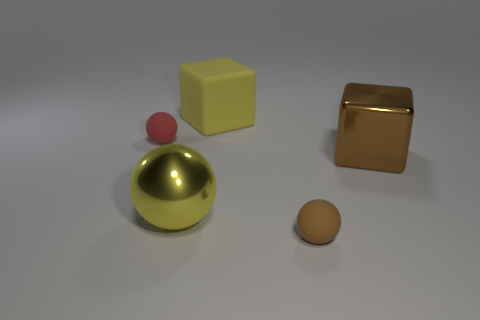There is a metallic thing that is the same shape as the yellow rubber object; what is its size?
Keep it short and to the point. Large. What number of other balls are made of the same material as the yellow ball?
Make the answer very short. 0. What material is the yellow sphere?
Keep it short and to the point. Metal. What is the shape of the small thing behind the metal cube that is in front of the red ball?
Offer a very short reply. Sphere. What is the shape of the yellow object that is to the left of the big matte thing?
Ensure brevity in your answer.  Sphere. What number of large shiny cubes have the same color as the big rubber cube?
Make the answer very short. 0. What color is the rubber block?
Your answer should be compact. Yellow. There is a ball behind the big brown object; what number of large metal balls are left of it?
Provide a short and direct response. 0. Do the brown matte sphere and the metal object that is left of the big brown metallic thing have the same size?
Make the answer very short. No. Is the yellow cube the same size as the brown rubber object?
Your answer should be very brief. No. 